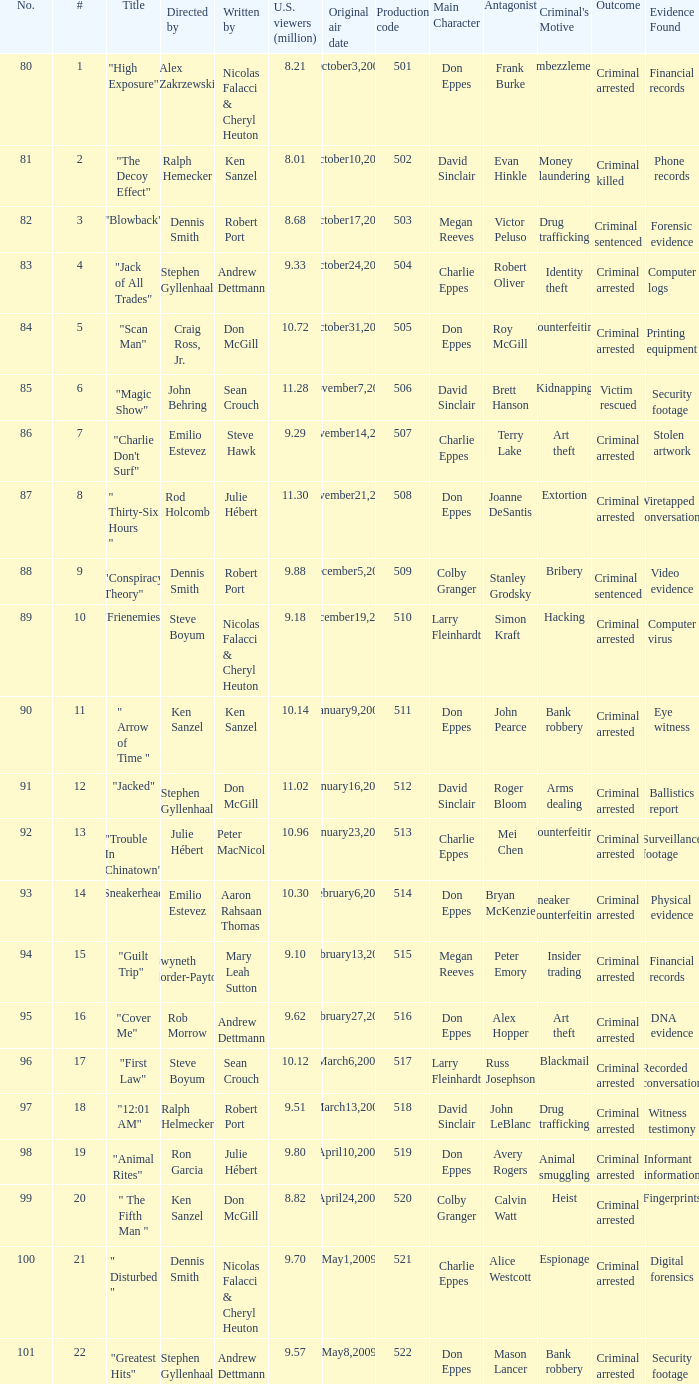What episode number was directed by Craig Ross, Jr. 5.0. 